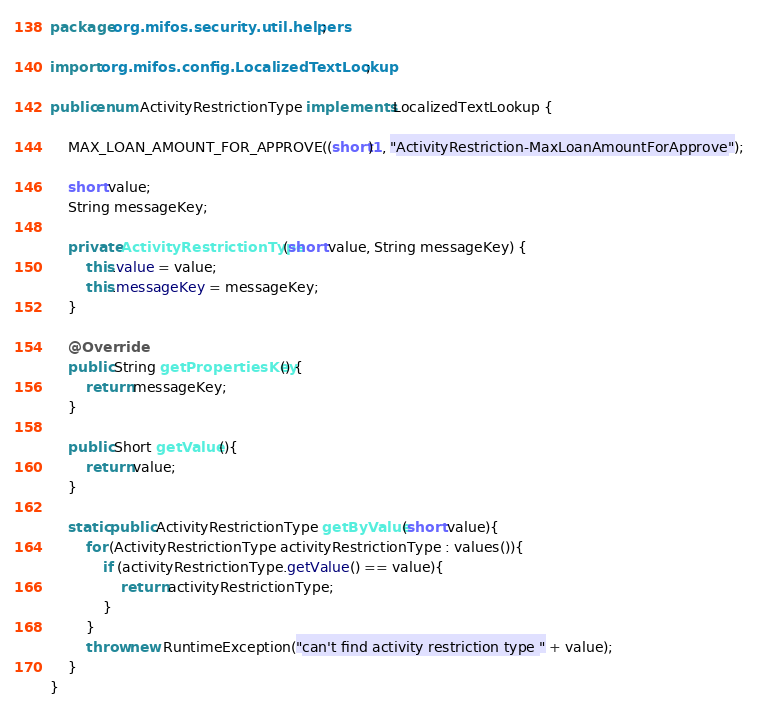<code> <loc_0><loc_0><loc_500><loc_500><_Java_>package org.mifos.security.util.helpers;

import org.mifos.config.LocalizedTextLookup;

public enum ActivityRestrictionType implements LocalizedTextLookup {

    MAX_LOAN_AMOUNT_FOR_APPROVE((short)1, "ActivityRestriction-MaxLoanAmountForApprove");
    
    short value;
    String messageKey;
    
    private ActivityRestrictionType(short value, String messageKey) {
        this.value = value;
        this.messageKey = messageKey;
    }

    @Override
    public String getPropertiesKey() {
        return messageKey;
    }

    public Short getValue(){
        return value;
    }
    
    static public ActivityRestrictionType getByValue(short value){
    	for (ActivityRestrictionType activityRestrictionType : values()){
    		if (activityRestrictionType.getValue() == value){
    			return activityRestrictionType;
    		}
    	}
    	throw new RuntimeException("can't find activity restriction type " + value);
    }
}
</code> 